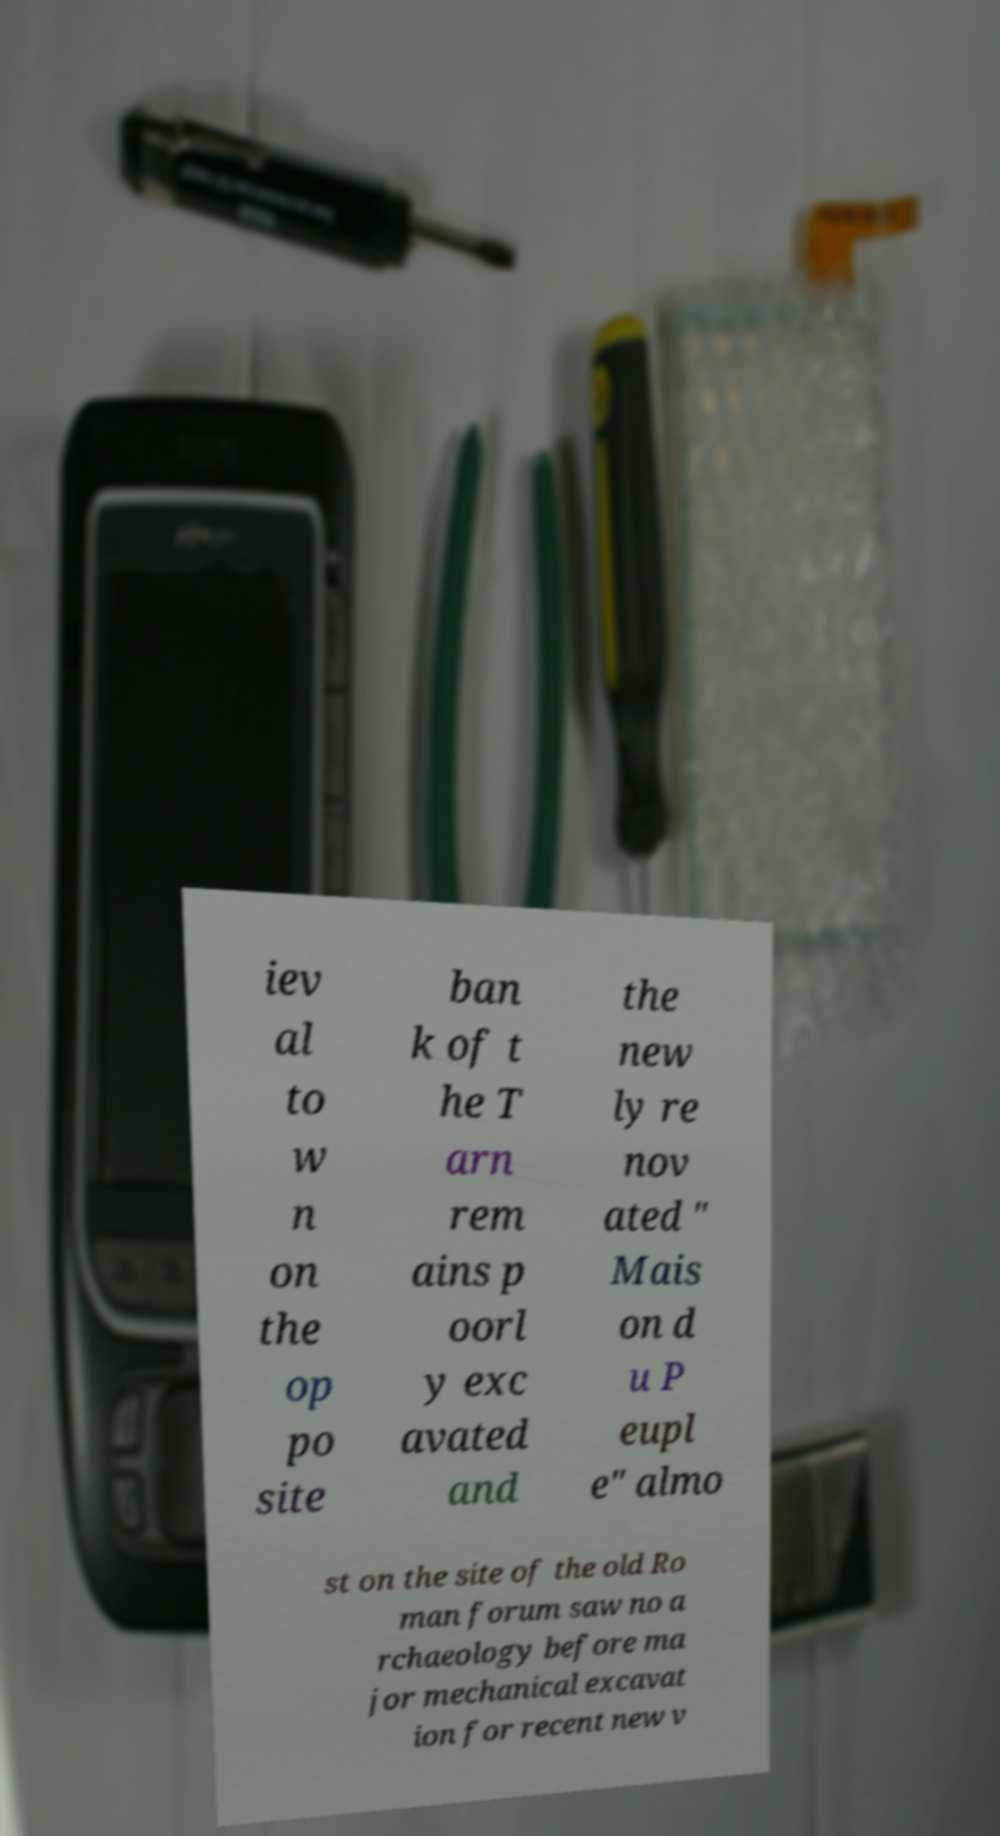I need the written content from this picture converted into text. Can you do that? iev al to w n on the op po site ban k of t he T arn rem ains p oorl y exc avated and the new ly re nov ated " Mais on d u P eupl e" almo st on the site of the old Ro man forum saw no a rchaeology before ma jor mechanical excavat ion for recent new v 